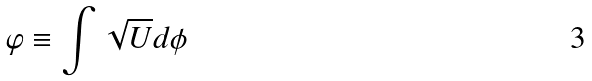<formula> <loc_0><loc_0><loc_500><loc_500>\varphi \equiv \int \sqrt { U } d \phi</formula> 